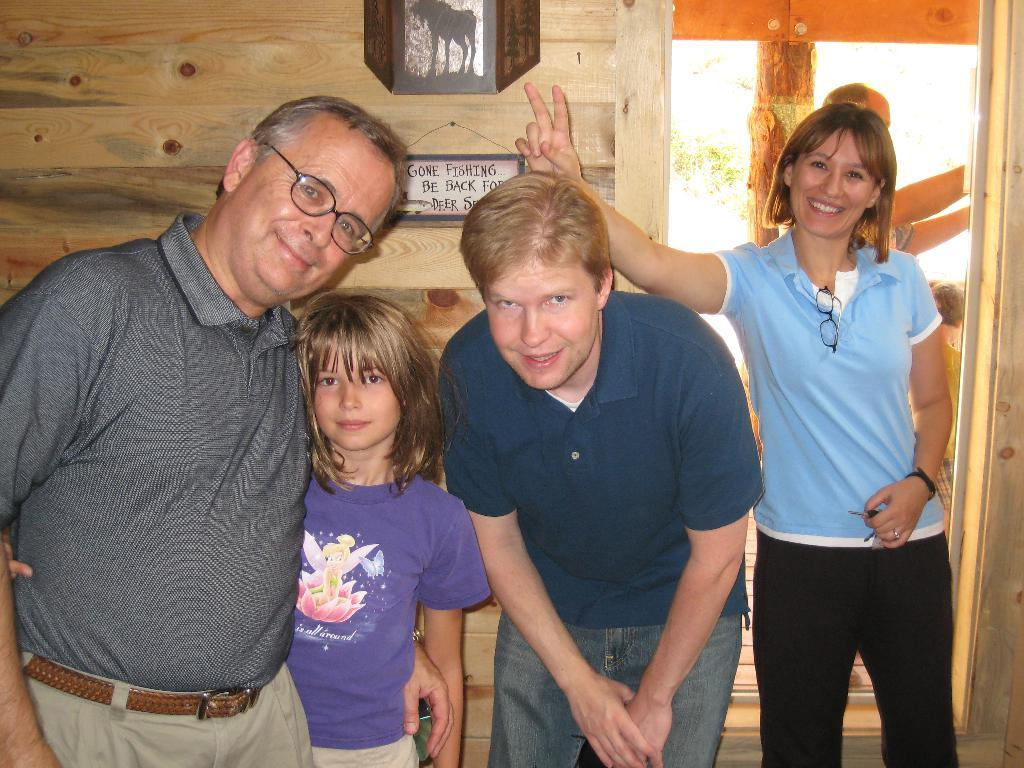What can be seen on the faces of the people in the image? The four people in the image are standing and smiling. How many people are at the back of the group? There are two people at the back of the four people. What is on the wall in the image? There is a name board on the wall in the image. What else can be seen in the image besides the people and the name board? There are some objects visible in the image. What type of popcorn is being shared among the friends in the image? There is no popcorn present in the image, and the people in the image are not identified as friends. How many icicles are hanging from the name board in the image? There are no icicles visible in the image, as it does not appear to be a cold or snowy environment. 